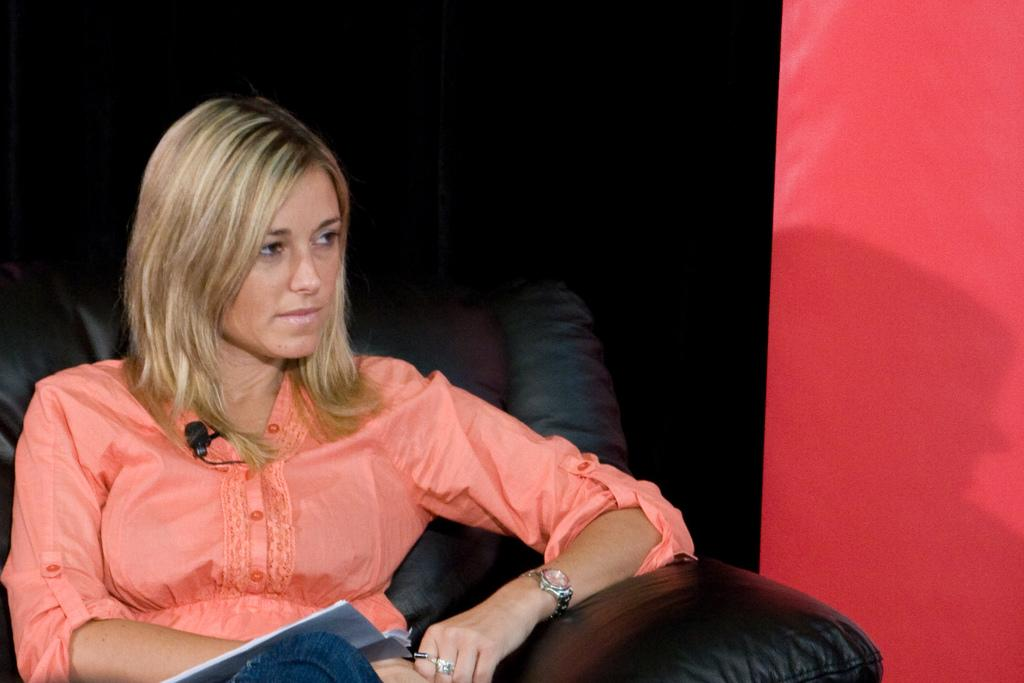Who or what is the main subject in the image? There is a person in the image. What is the person holding in the image? The person is holding a microphone. What is the person sitting on in the image? The person is sitting on a sofa. What else is the person holding in the image? The person is holding an object, which is the microphone. What can be seen in the background of the image? There is a wall visible in the image. What type of pipe can be seen in the image? There is no pipe present in the image. What is the person doing with the quince in the image? There is no quince present in the image, and the person is holding a microphone, not a quince. 